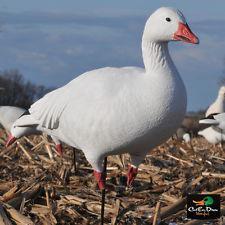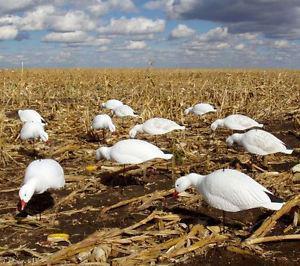The first image is the image on the left, the second image is the image on the right. Analyze the images presented: Is the assertion "Has atleast one picture with 6 or less ducks." valid? Answer yes or no. Yes. The first image is the image on the left, the second image is the image on the right. For the images displayed, is the sentence "Duck decoys, including white duck forms with heads bent down, are in a field of yellow straw in one image." factually correct? Answer yes or no. Yes. 